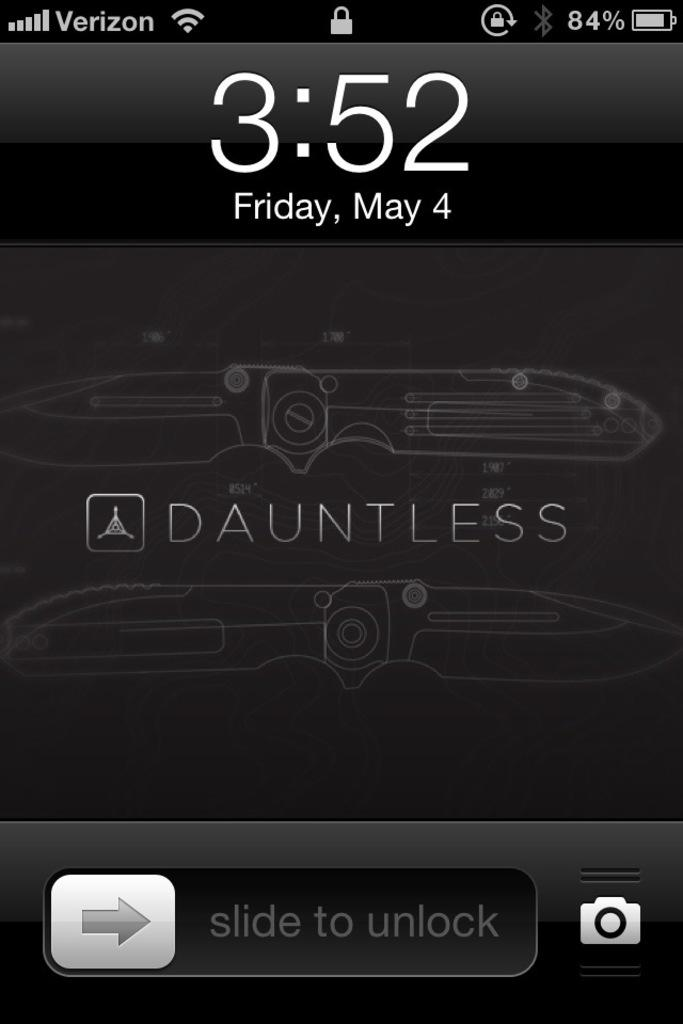<image>
Share a concise interpretation of the image provided. The lock screen of an iphone shows the date as Friday the 4th of May. 